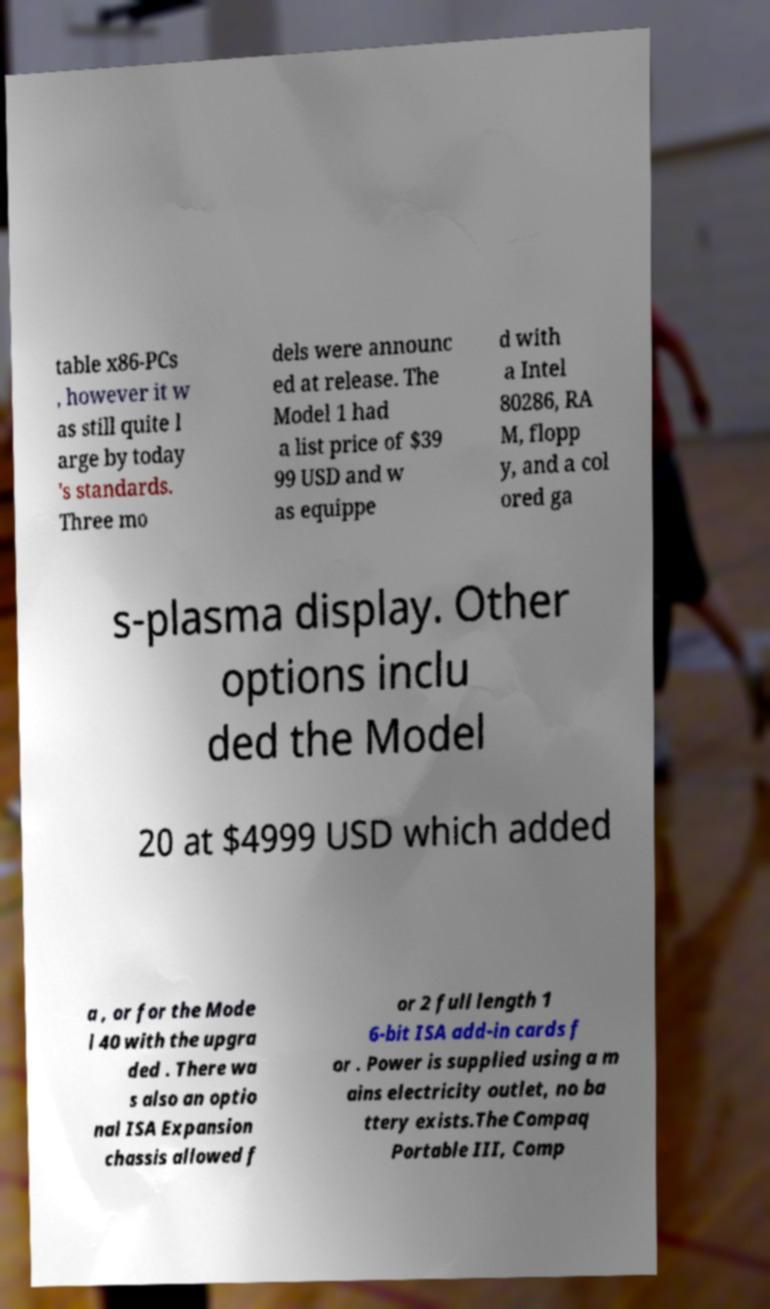There's text embedded in this image that I need extracted. Can you transcribe it verbatim? table x86-PCs , however it w as still quite l arge by today 's standards. Three mo dels were announc ed at release. The Model 1 had a list price of $39 99 USD and w as equippe d with a Intel 80286, RA M, flopp y, and a col ored ga s-plasma display. Other options inclu ded the Model 20 at $4999 USD which added a , or for the Mode l 40 with the upgra ded . There wa s also an optio nal ISA Expansion chassis allowed f or 2 full length 1 6-bit ISA add-in cards f or . Power is supplied using a m ains electricity outlet, no ba ttery exists.The Compaq Portable III, Comp 